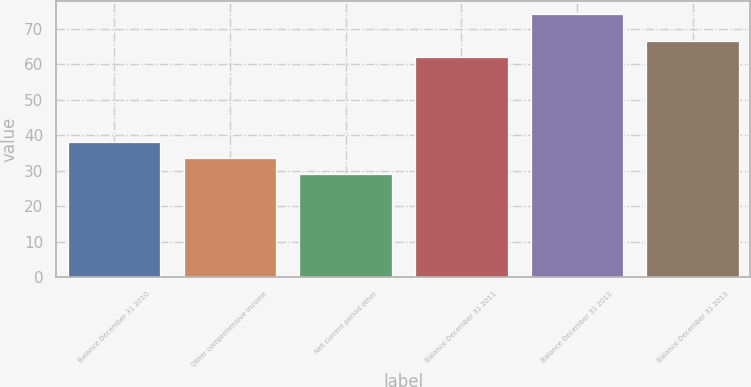Convert chart. <chart><loc_0><loc_0><loc_500><loc_500><bar_chart><fcel>Balance December 31 2010<fcel>Other comprehensive income<fcel>Net current period other<fcel>Balance December 31 2011<fcel>Balance December 31 2012<fcel>Balance December 31 2013<nl><fcel>38<fcel>33.5<fcel>29<fcel>62<fcel>74<fcel>66.5<nl></chart> 